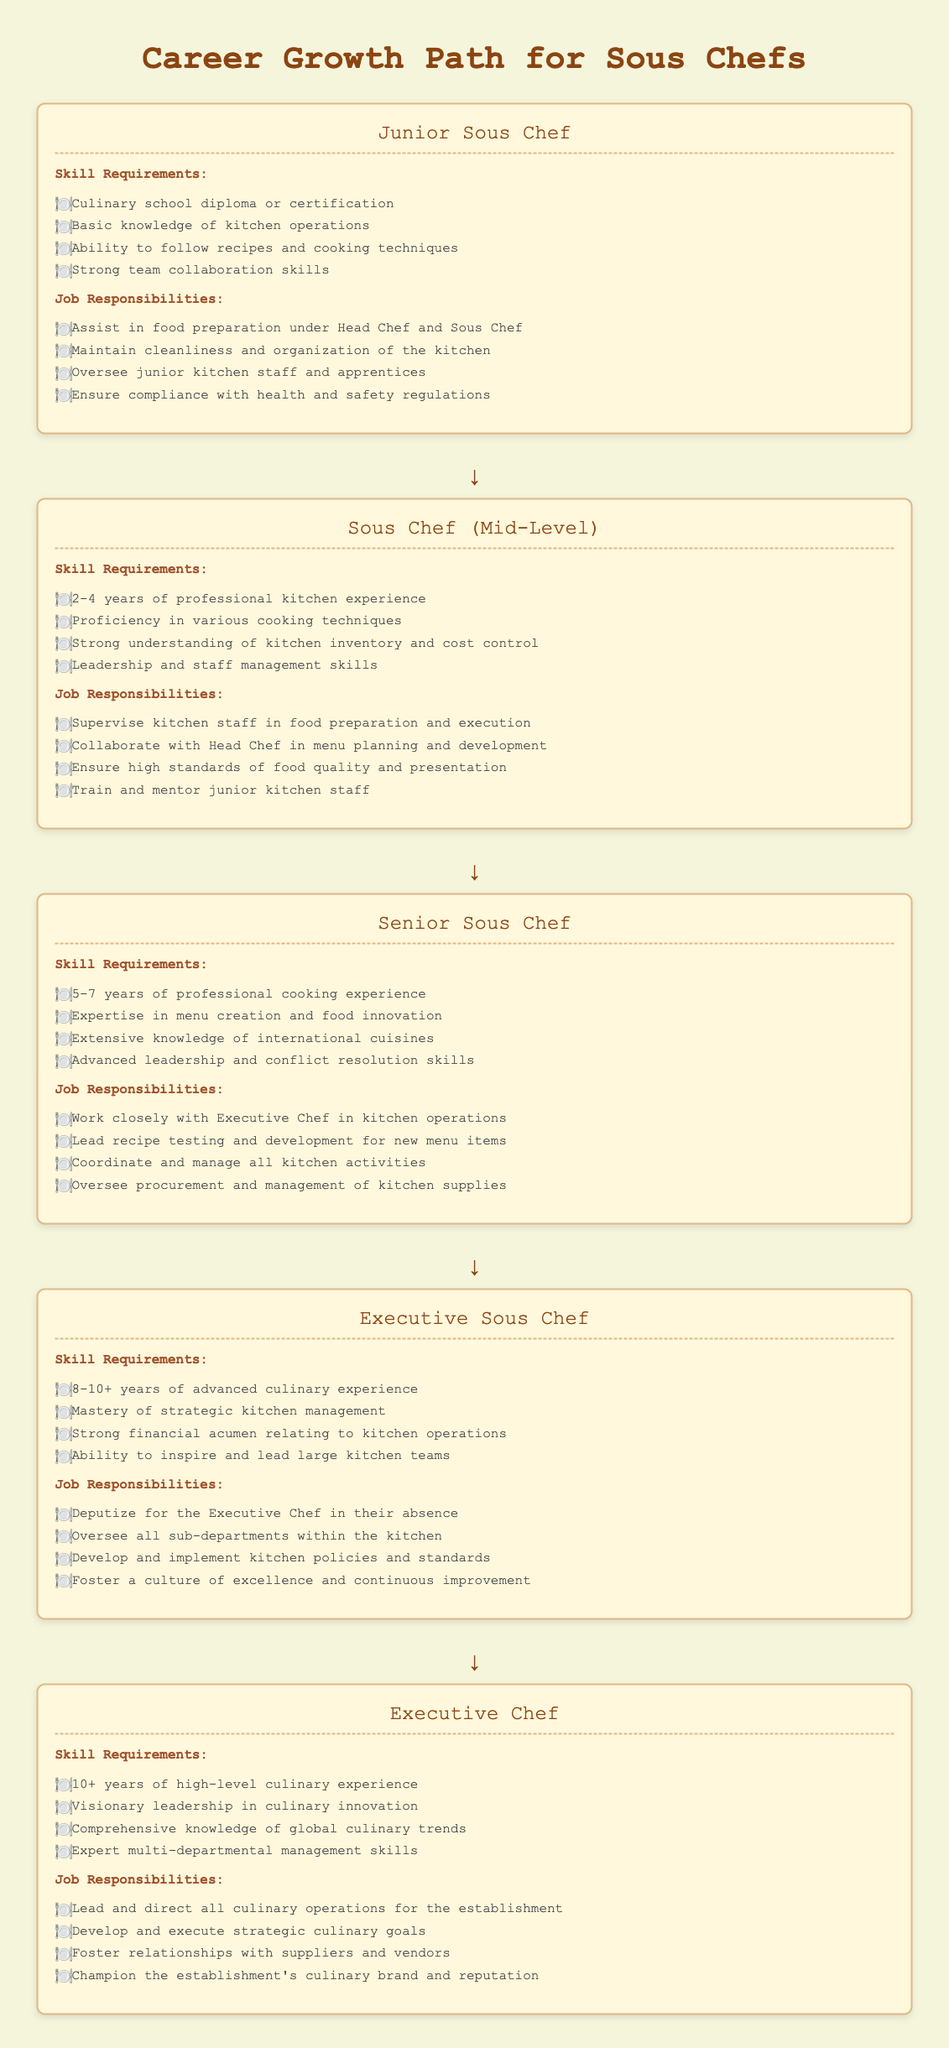what is the title of the document? The title is prominently displayed at the top of the document, indicating the main topic it covers.
Answer: Career Growth Path for Sous Chefs how many years of experience is needed for the Senior Sous Chef position? The document specifies the years of experience required for each role, particularly noting the requirements for Senior Sous Chef.
Answer: 5-7 years what is one skill required for the Junior Sous Chef? The document lists specific skills required for each position, including those for the Junior Sous Chef.
Answer: Culinary school diploma or certification which position requires 10+ years of culinary experience? The document outlines the experience levels associated with each role, particularly highlighting the Executive Chef position.
Answer: Executive Chef who does the Executive Sous Chef deputize for in their absence? The responsibilities associated with the role of Executive Sous Chef include key functions that clarify this specific duty.
Answer: Executive Chef which job responsibility is shared by both Sous Chef and Senior Sous Chef? The document describes similar responsibilities across different positions, prompting reasoning about shared duties.
Answer: Train and mentor junior kitchen staff 